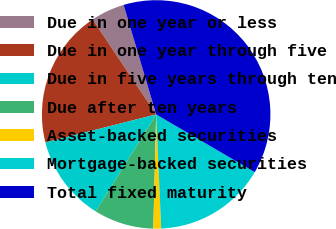Convert chart to OTSL. <chart><loc_0><loc_0><loc_500><loc_500><pie_chart><fcel>Due in one year or less<fcel>Due in one year through five<fcel>Due in five years through ten<fcel>Due after ten years<fcel>Asset-backed securities<fcel>Mortgage-backed securities<fcel>Total fixed maturity<nl><fcel>4.79%<fcel>19.56%<fcel>12.18%<fcel>8.48%<fcel>1.1%<fcel>15.87%<fcel>38.02%<nl></chart> 